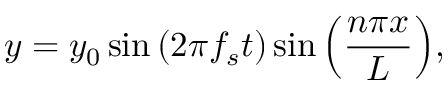<formula> <loc_0><loc_0><loc_500><loc_500>y = y _ { 0 } \sin { ( 2 \pi f _ { s } t ) } \sin { \left ( \frac { n \pi x } { L } \right ) } ,</formula> 